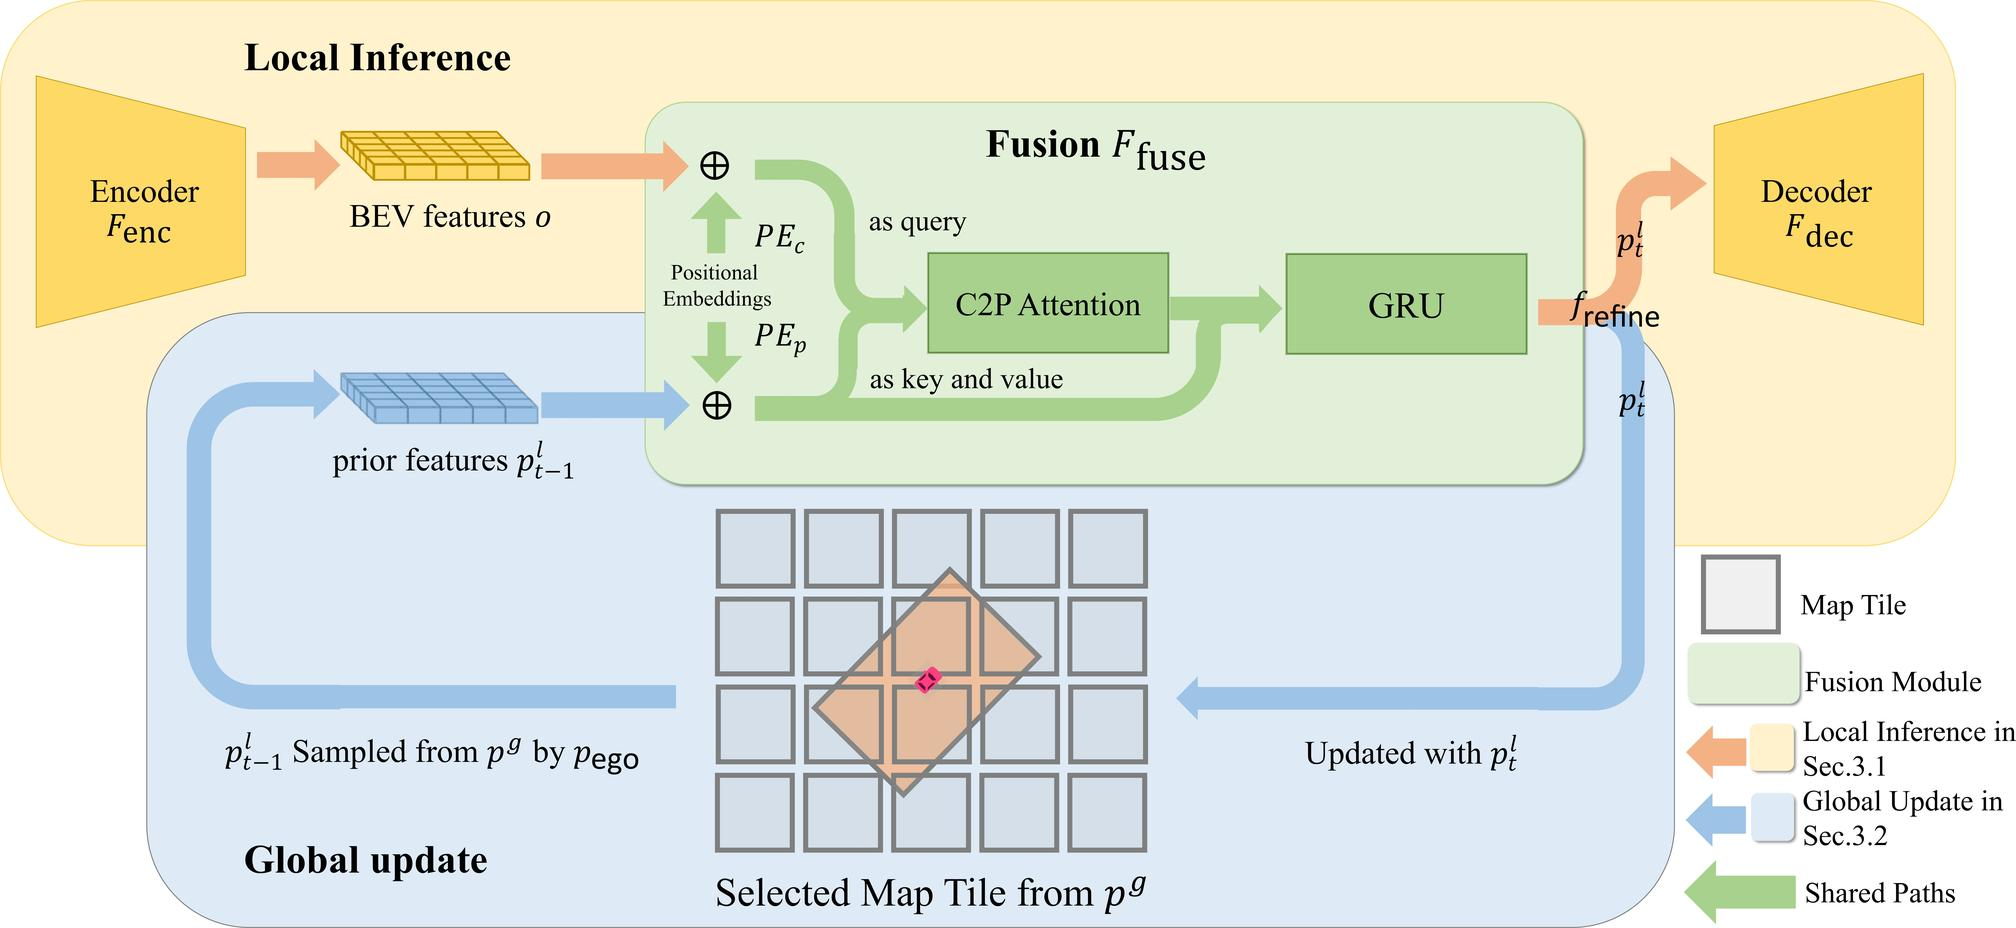How does the fusion module interact with the local inference and global update in the system depicted? In the depicted system, the fusion module serves as a critical intermediary that bridges the local inference process and the global update mechanism. Initially, the encoder generates BEV features that are combined with prior features by local inference. The fusion module then uses these combined features, processes them through the C2P Attention and GRU to refine and update the features, which are finally sent to the global update. This process ensures a continuous and coherent integration of new sensory data and past information, optimizing the system's overall responsiveness and accuracy in real-time navigation tasks. 